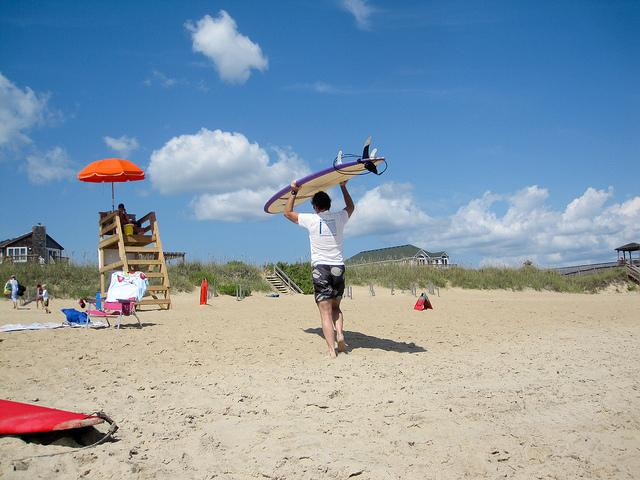What kind of view might be seen from the windows on the house? ocean 